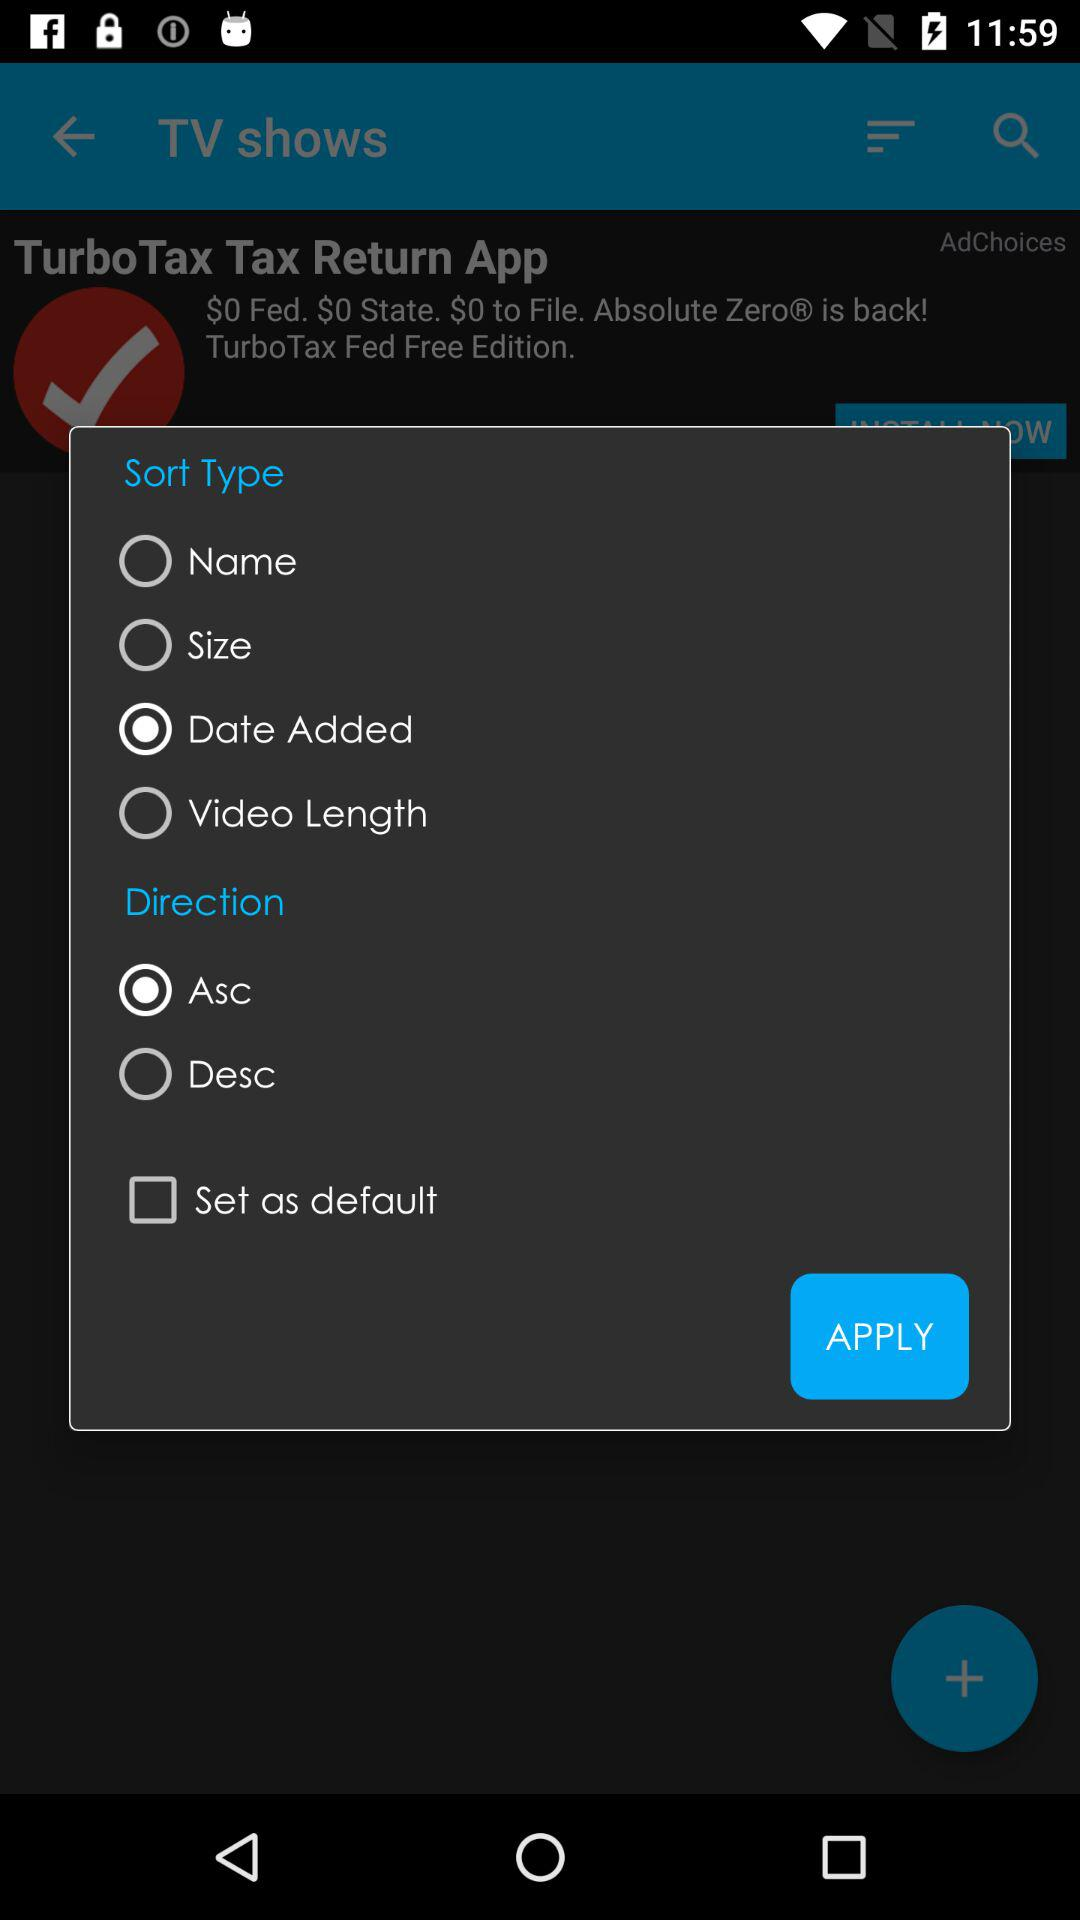What is the option selected for "Sort Type"? The selected option is "Date Added". 